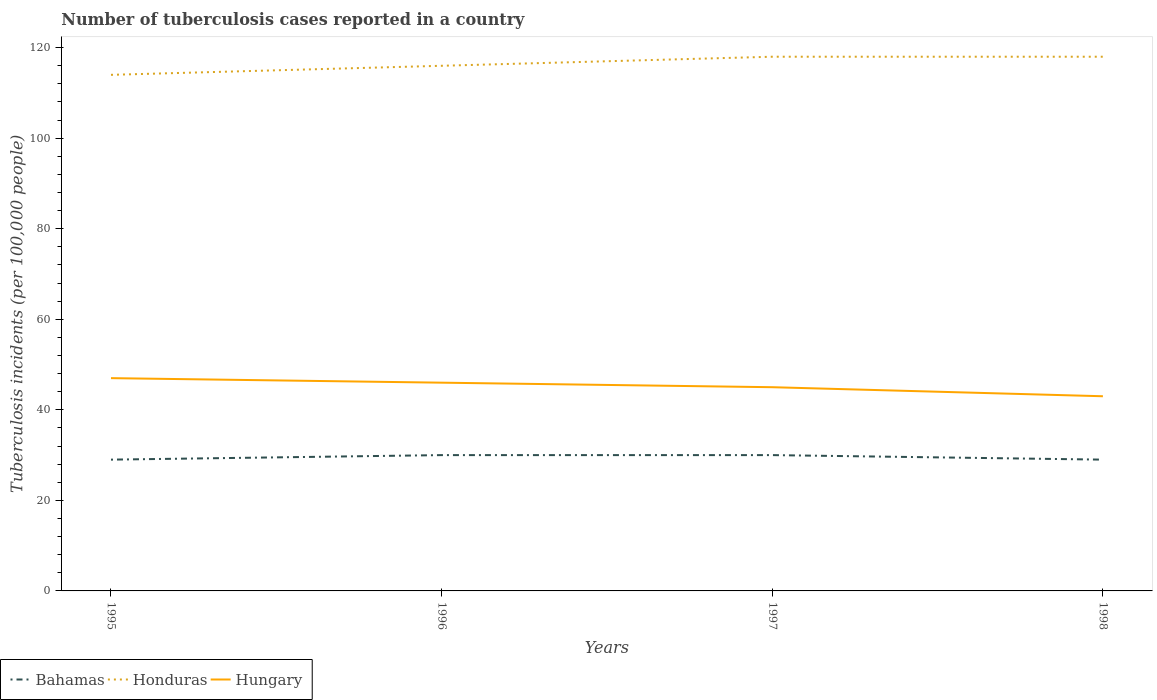How many different coloured lines are there?
Provide a short and direct response. 3. Across all years, what is the maximum number of tuberculosis cases reported in in Honduras?
Make the answer very short. 114. What is the total number of tuberculosis cases reported in in Bahamas in the graph?
Keep it short and to the point. 1. What is the difference between the highest and the second highest number of tuberculosis cases reported in in Hungary?
Your response must be concise. 4. What is the difference between the highest and the lowest number of tuberculosis cases reported in in Bahamas?
Your answer should be very brief. 2. How many lines are there?
Offer a terse response. 3. How many years are there in the graph?
Your answer should be very brief. 4. Are the values on the major ticks of Y-axis written in scientific E-notation?
Offer a very short reply. No. Does the graph contain any zero values?
Keep it short and to the point. No. Does the graph contain grids?
Provide a short and direct response. No. How are the legend labels stacked?
Offer a terse response. Horizontal. What is the title of the graph?
Keep it short and to the point. Number of tuberculosis cases reported in a country. Does "Mozambique" appear as one of the legend labels in the graph?
Ensure brevity in your answer.  No. What is the label or title of the Y-axis?
Give a very brief answer. Tuberculosis incidents (per 100,0 people). What is the Tuberculosis incidents (per 100,000 people) in Bahamas in 1995?
Your answer should be compact. 29. What is the Tuberculosis incidents (per 100,000 people) in Honduras in 1995?
Your response must be concise. 114. What is the Tuberculosis incidents (per 100,000 people) of Bahamas in 1996?
Provide a succinct answer. 30. What is the Tuberculosis incidents (per 100,000 people) of Honduras in 1996?
Your response must be concise. 116. What is the Tuberculosis incidents (per 100,000 people) of Hungary in 1996?
Provide a short and direct response. 46. What is the Tuberculosis incidents (per 100,000 people) of Honduras in 1997?
Keep it short and to the point. 118. What is the Tuberculosis incidents (per 100,000 people) in Honduras in 1998?
Provide a succinct answer. 118. What is the Tuberculosis incidents (per 100,000 people) of Hungary in 1998?
Give a very brief answer. 43. Across all years, what is the maximum Tuberculosis incidents (per 100,000 people) of Honduras?
Provide a short and direct response. 118. Across all years, what is the minimum Tuberculosis incidents (per 100,000 people) in Honduras?
Your answer should be compact. 114. Across all years, what is the minimum Tuberculosis incidents (per 100,000 people) in Hungary?
Your response must be concise. 43. What is the total Tuberculosis incidents (per 100,000 people) of Bahamas in the graph?
Make the answer very short. 118. What is the total Tuberculosis incidents (per 100,000 people) of Honduras in the graph?
Offer a terse response. 466. What is the total Tuberculosis incidents (per 100,000 people) of Hungary in the graph?
Give a very brief answer. 181. What is the difference between the Tuberculosis incidents (per 100,000 people) in Bahamas in 1995 and that in 1996?
Provide a short and direct response. -1. What is the difference between the Tuberculosis incidents (per 100,000 people) in Bahamas in 1995 and that in 1997?
Ensure brevity in your answer.  -1. What is the difference between the Tuberculosis incidents (per 100,000 people) of Hungary in 1995 and that in 1997?
Offer a very short reply. 2. What is the difference between the Tuberculosis incidents (per 100,000 people) in Honduras in 1995 and that in 1998?
Offer a terse response. -4. What is the difference between the Tuberculosis incidents (per 100,000 people) of Hungary in 1995 and that in 1998?
Make the answer very short. 4. What is the difference between the Tuberculosis incidents (per 100,000 people) in Bahamas in 1996 and that in 1997?
Ensure brevity in your answer.  0. What is the difference between the Tuberculosis incidents (per 100,000 people) of Bahamas in 1997 and that in 1998?
Your answer should be very brief. 1. What is the difference between the Tuberculosis incidents (per 100,000 people) of Bahamas in 1995 and the Tuberculosis incidents (per 100,000 people) of Honduras in 1996?
Provide a succinct answer. -87. What is the difference between the Tuberculosis incidents (per 100,000 people) of Bahamas in 1995 and the Tuberculosis incidents (per 100,000 people) of Hungary in 1996?
Offer a very short reply. -17. What is the difference between the Tuberculosis incidents (per 100,000 people) of Honduras in 1995 and the Tuberculosis incidents (per 100,000 people) of Hungary in 1996?
Provide a short and direct response. 68. What is the difference between the Tuberculosis incidents (per 100,000 people) in Bahamas in 1995 and the Tuberculosis incidents (per 100,000 people) in Honduras in 1997?
Give a very brief answer. -89. What is the difference between the Tuberculosis incidents (per 100,000 people) in Bahamas in 1995 and the Tuberculosis incidents (per 100,000 people) in Hungary in 1997?
Offer a very short reply. -16. What is the difference between the Tuberculosis incidents (per 100,000 people) of Bahamas in 1995 and the Tuberculosis incidents (per 100,000 people) of Honduras in 1998?
Your answer should be compact. -89. What is the difference between the Tuberculosis incidents (per 100,000 people) in Bahamas in 1995 and the Tuberculosis incidents (per 100,000 people) in Hungary in 1998?
Give a very brief answer. -14. What is the difference between the Tuberculosis incidents (per 100,000 people) of Honduras in 1995 and the Tuberculosis incidents (per 100,000 people) of Hungary in 1998?
Provide a short and direct response. 71. What is the difference between the Tuberculosis incidents (per 100,000 people) in Bahamas in 1996 and the Tuberculosis incidents (per 100,000 people) in Honduras in 1997?
Provide a short and direct response. -88. What is the difference between the Tuberculosis incidents (per 100,000 people) in Bahamas in 1996 and the Tuberculosis incidents (per 100,000 people) in Hungary in 1997?
Give a very brief answer. -15. What is the difference between the Tuberculosis incidents (per 100,000 people) in Bahamas in 1996 and the Tuberculosis incidents (per 100,000 people) in Honduras in 1998?
Keep it short and to the point. -88. What is the difference between the Tuberculosis incidents (per 100,000 people) of Bahamas in 1996 and the Tuberculosis incidents (per 100,000 people) of Hungary in 1998?
Keep it short and to the point. -13. What is the difference between the Tuberculosis incidents (per 100,000 people) in Honduras in 1996 and the Tuberculosis incidents (per 100,000 people) in Hungary in 1998?
Provide a short and direct response. 73. What is the difference between the Tuberculosis incidents (per 100,000 people) in Bahamas in 1997 and the Tuberculosis incidents (per 100,000 people) in Honduras in 1998?
Make the answer very short. -88. What is the difference between the Tuberculosis incidents (per 100,000 people) of Bahamas in 1997 and the Tuberculosis incidents (per 100,000 people) of Hungary in 1998?
Make the answer very short. -13. What is the average Tuberculosis incidents (per 100,000 people) of Bahamas per year?
Your answer should be compact. 29.5. What is the average Tuberculosis incidents (per 100,000 people) of Honduras per year?
Keep it short and to the point. 116.5. What is the average Tuberculosis incidents (per 100,000 people) in Hungary per year?
Your answer should be compact. 45.25. In the year 1995, what is the difference between the Tuberculosis incidents (per 100,000 people) in Bahamas and Tuberculosis incidents (per 100,000 people) in Honduras?
Your response must be concise. -85. In the year 1995, what is the difference between the Tuberculosis incidents (per 100,000 people) of Honduras and Tuberculosis incidents (per 100,000 people) of Hungary?
Offer a very short reply. 67. In the year 1996, what is the difference between the Tuberculosis incidents (per 100,000 people) of Bahamas and Tuberculosis incidents (per 100,000 people) of Honduras?
Offer a very short reply. -86. In the year 1996, what is the difference between the Tuberculosis incidents (per 100,000 people) in Honduras and Tuberculosis incidents (per 100,000 people) in Hungary?
Your answer should be very brief. 70. In the year 1997, what is the difference between the Tuberculosis incidents (per 100,000 people) of Bahamas and Tuberculosis incidents (per 100,000 people) of Honduras?
Offer a terse response. -88. In the year 1997, what is the difference between the Tuberculosis incidents (per 100,000 people) of Bahamas and Tuberculosis incidents (per 100,000 people) of Hungary?
Your answer should be compact. -15. In the year 1998, what is the difference between the Tuberculosis incidents (per 100,000 people) in Bahamas and Tuberculosis incidents (per 100,000 people) in Honduras?
Your response must be concise. -89. In the year 1998, what is the difference between the Tuberculosis incidents (per 100,000 people) in Bahamas and Tuberculosis incidents (per 100,000 people) in Hungary?
Ensure brevity in your answer.  -14. What is the ratio of the Tuberculosis incidents (per 100,000 people) of Bahamas in 1995 to that in 1996?
Your answer should be compact. 0.97. What is the ratio of the Tuberculosis incidents (per 100,000 people) in Honduras in 1995 to that in 1996?
Make the answer very short. 0.98. What is the ratio of the Tuberculosis incidents (per 100,000 people) of Hungary in 1995 to that in 1996?
Your answer should be compact. 1.02. What is the ratio of the Tuberculosis incidents (per 100,000 people) of Bahamas in 1995 to that in 1997?
Offer a very short reply. 0.97. What is the ratio of the Tuberculosis incidents (per 100,000 people) in Honduras in 1995 to that in 1997?
Your response must be concise. 0.97. What is the ratio of the Tuberculosis incidents (per 100,000 people) in Hungary in 1995 to that in 1997?
Provide a short and direct response. 1.04. What is the ratio of the Tuberculosis incidents (per 100,000 people) in Bahamas in 1995 to that in 1998?
Offer a terse response. 1. What is the ratio of the Tuberculosis incidents (per 100,000 people) of Honduras in 1995 to that in 1998?
Offer a terse response. 0.97. What is the ratio of the Tuberculosis incidents (per 100,000 people) in Hungary in 1995 to that in 1998?
Offer a very short reply. 1.09. What is the ratio of the Tuberculosis incidents (per 100,000 people) of Honduras in 1996 to that in 1997?
Offer a very short reply. 0.98. What is the ratio of the Tuberculosis incidents (per 100,000 people) of Hungary in 1996 to that in 1997?
Ensure brevity in your answer.  1.02. What is the ratio of the Tuberculosis incidents (per 100,000 people) of Bahamas in 1996 to that in 1998?
Provide a short and direct response. 1.03. What is the ratio of the Tuberculosis incidents (per 100,000 people) in Honduras in 1996 to that in 1998?
Offer a terse response. 0.98. What is the ratio of the Tuberculosis incidents (per 100,000 people) in Hungary in 1996 to that in 1998?
Your response must be concise. 1.07. What is the ratio of the Tuberculosis incidents (per 100,000 people) in Bahamas in 1997 to that in 1998?
Your answer should be very brief. 1.03. What is the ratio of the Tuberculosis incidents (per 100,000 people) of Honduras in 1997 to that in 1998?
Give a very brief answer. 1. What is the ratio of the Tuberculosis incidents (per 100,000 people) in Hungary in 1997 to that in 1998?
Provide a succinct answer. 1.05. What is the difference between the highest and the second highest Tuberculosis incidents (per 100,000 people) of Hungary?
Provide a short and direct response. 1. 